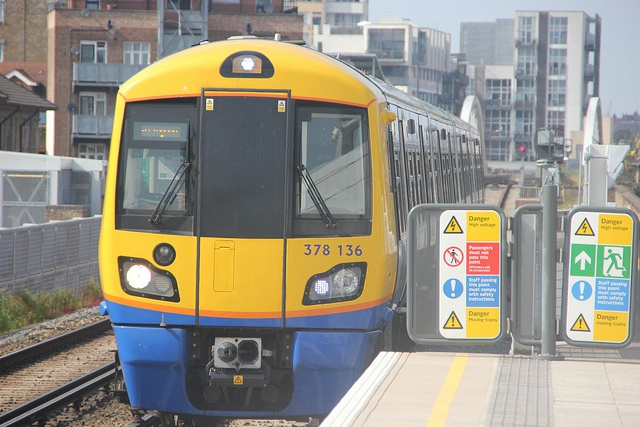Describe the objects in this image and their specific colors. I can see a train in gray, darkgray, and orange tones in this image. 